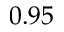Convert formula to latex. <formula><loc_0><loc_0><loc_500><loc_500>0 . 9 5</formula> 